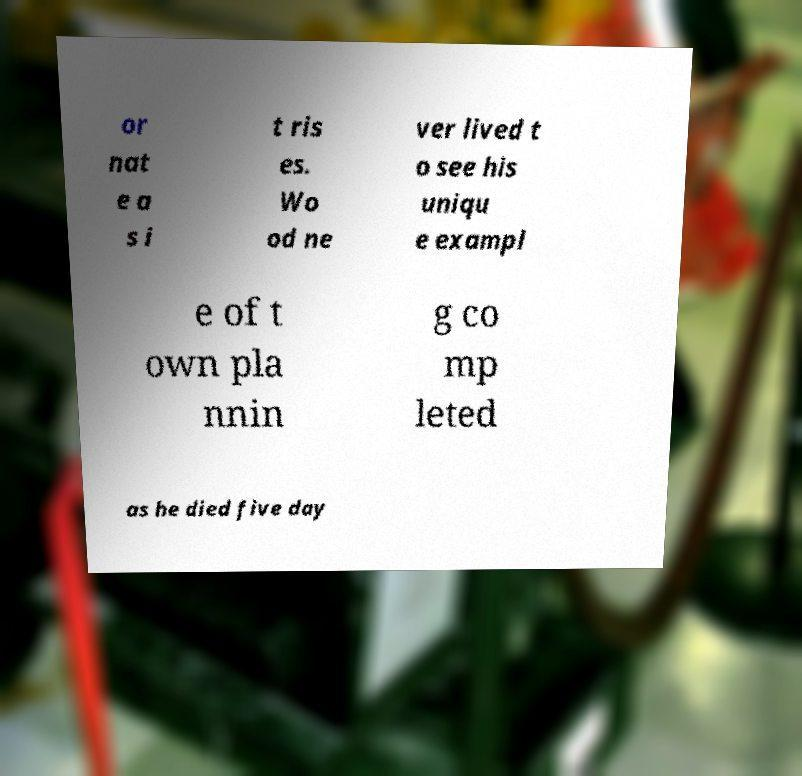For documentation purposes, I need the text within this image transcribed. Could you provide that? or nat e a s i t ris es. Wo od ne ver lived t o see his uniqu e exampl e of t own pla nnin g co mp leted as he died five day 